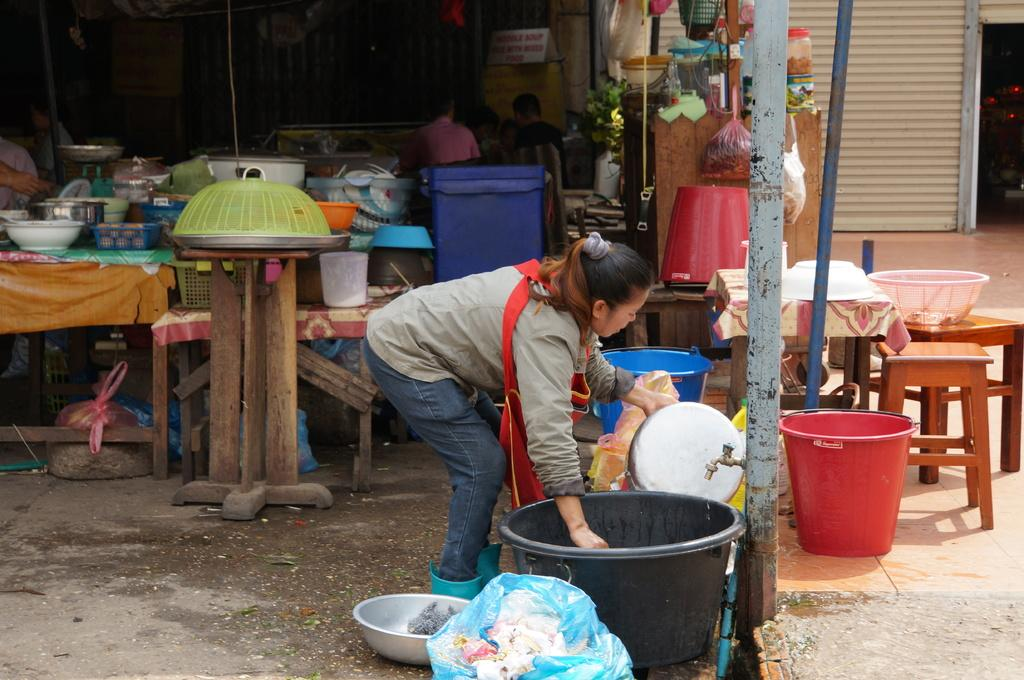Who is present in the image? There is a woman in the image. What is the woman doing in the image? The woman is watching utensils. What object can be seen in the image that is black and tub-like? There is a black tub in the image. Are there any other people visible in the image? Yes, there are people standing at the back of the image. What type of drug can be seen in the woman's hand in the image? There is no drug present in the image; the woman is watching utensils. What kind of wire is connected to the black tub in the image? There is no wire connected to the black tub in the image; it is just a tub. 